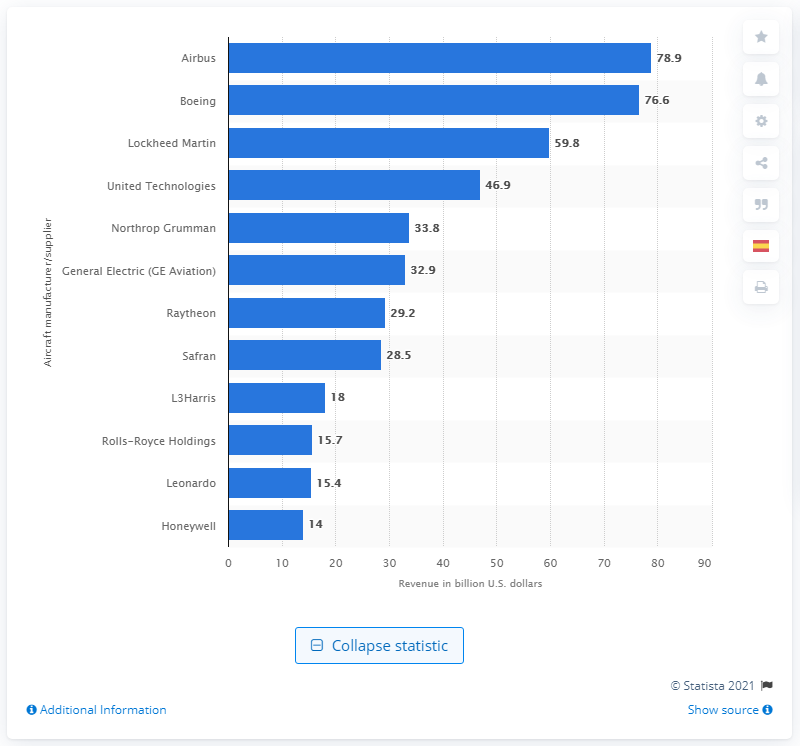Point out several critical features in this image. In 2019, Boeing's global revenue was 76.6 billion dollars. 